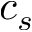<formula> <loc_0><loc_0><loc_500><loc_500>c _ { s }</formula> 